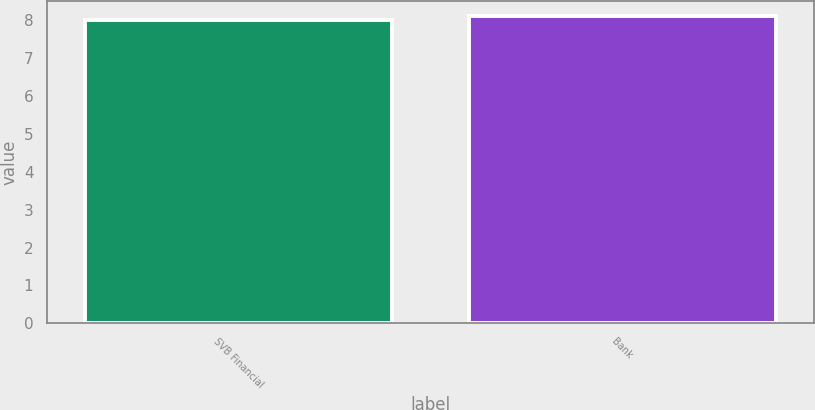Convert chart. <chart><loc_0><loc_0><loc_500><loc_500><bar_chart><fcel>SVB Financial<fcel>Bank<nl><fcel>8<fcel>8.1<nl></chart> 